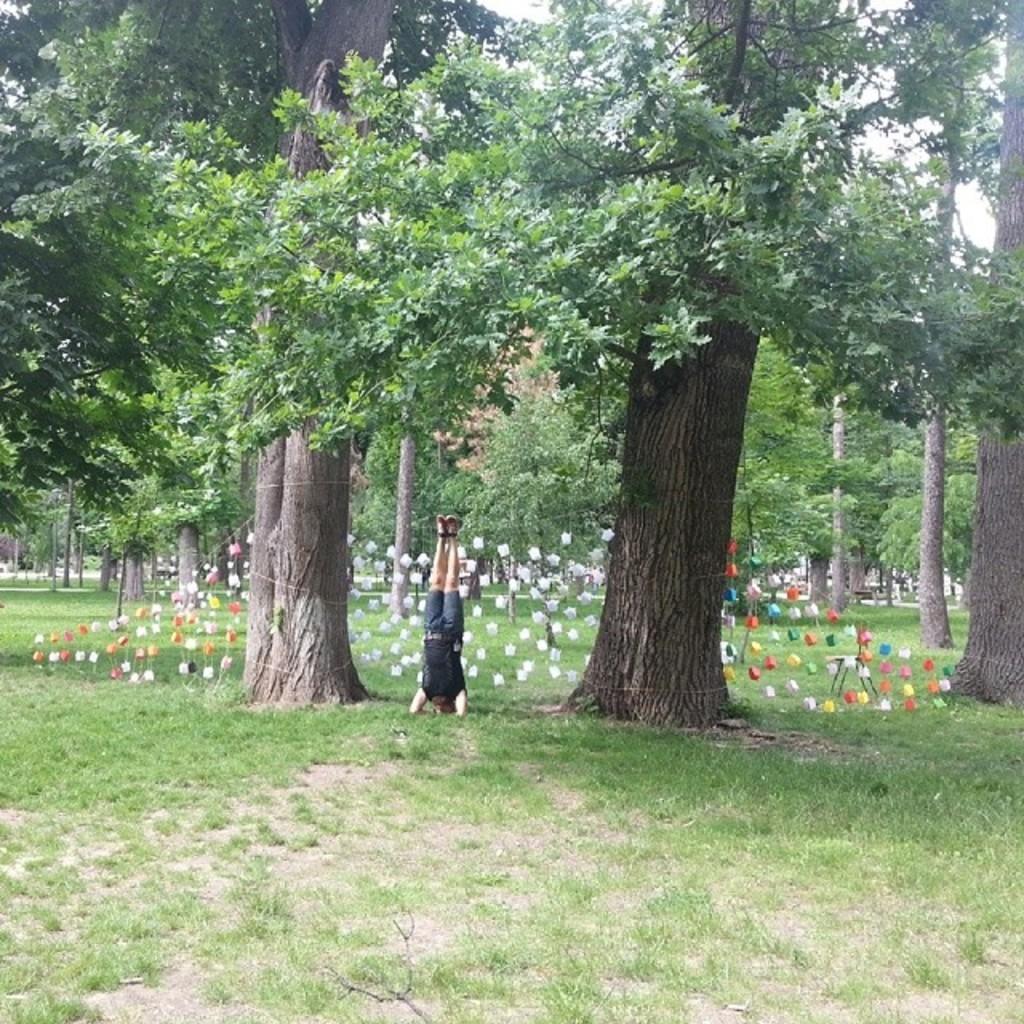Could you give a brief overview of what you see in this image? At the bottom of the image on the ground there is grass. There is a man in the inverted position. Behind him there are few objects hanging on the ropes. In the background there are trees. 